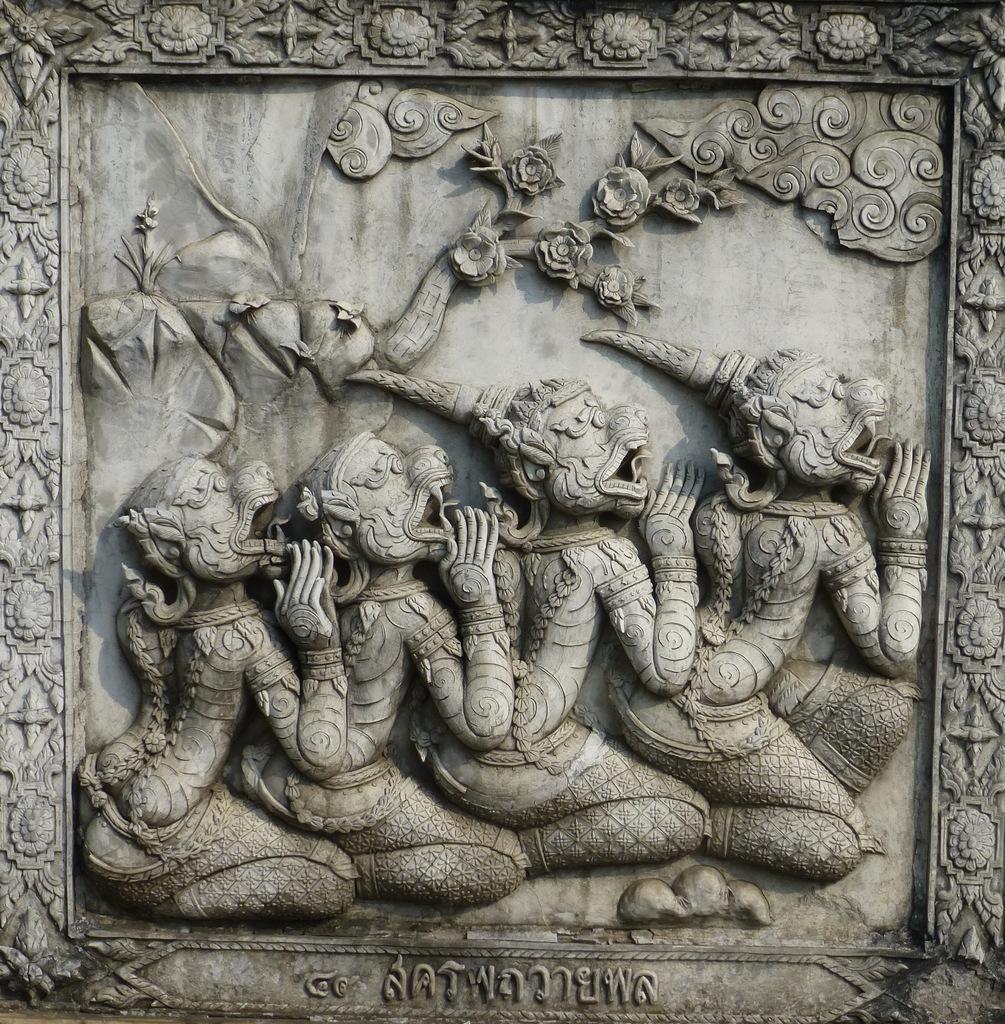Please provide a concise description of this image. In this picture we can see sculpture here, at the bottom there is some text. 